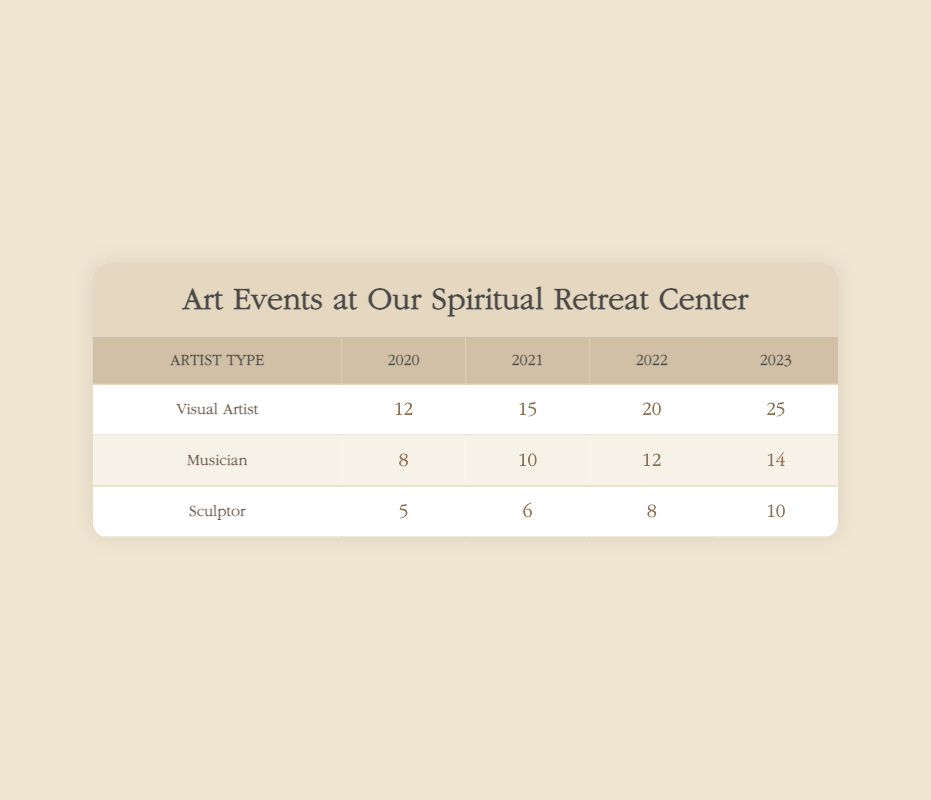What is the total number of events for Visual Artists from 2020 to 2023? To find the total, add the event counts for Visual Artists for each year: 12 (2020) + 15 (2021) + 20 (2022) + 25 (2023) = 72.
Answer: 72 Which artist type had the highest event count in 2022? In 2022, Visual Artists had 20 events, Musicians had 12 events, and Sculptors had 8 events. Therefore, Visual Artists had the highest event count.
Answer: Visual Artist How many events did Musicians have from 2020 to 2023 combined? To find the total for Musicians, add their event counts from each year: 8 (2020) + 10 (2021) + 12 (2022) + 14 (2023) = 54.
Answer: 54 What was the average number of events for Sculptors from 2020 to 2023? To calculate the average, sum the event counts for Sculptors: 5 (2020) + 6 (2021) + 8 (2022) + 10 (2023) = 29. Then, divide by the number of years, which is 4: 29/4 = 7.25.
Answer: 7.25 Did the total number of events for Musicians increase from 2020 to 2023? To determine if there was an increase, compare the event counts: 8 events in 2020 and 14 events in 2023. Since 14 is greater than 8, there is an increase.
Answer: Yes What is the difference in event counts for Visual Artists between 2020 and 2023? The number of events for Visual Artists in 2023 is 25, and in 2020 it is 12. The difference is calculated by subtracting: 25 - 12 = 13.
Answer: 13 Which year had the least number of events for Sculptors? Examining the event counts for Sculptors: 5 (2020), 6 (2021), 8 (2022), and 10 (2023). The least number of events is in 2020 with 5 events.
Answer: 2020 Is the number of events for Musicians steadily increasing each year? The event counts for Musicians are 8 (2020), 10 (2021), 12 (2022), and 14 (2023). Each subsequent year shows a higher count, indicating a steady increase.
Answer: Yes What artist type shows the most significant growth in event counts from 2020 to 2023? The growth for each artist type can be calculated: Visual Artists grew from 12 to 25 (+13), Musicians from 8 to 14 (+6), and Sculptors from 5 to 10 (+5). The most significant growth is for Visual Artists with an increase of 13.
Answer: Visual Artist 